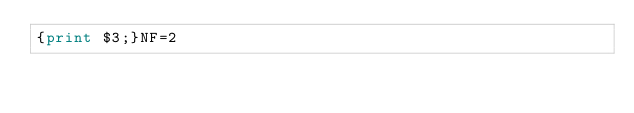<code> <loc_0><loc_0><loc_500><loc_500><_Awk_>{print $3;}NF=2</code> 